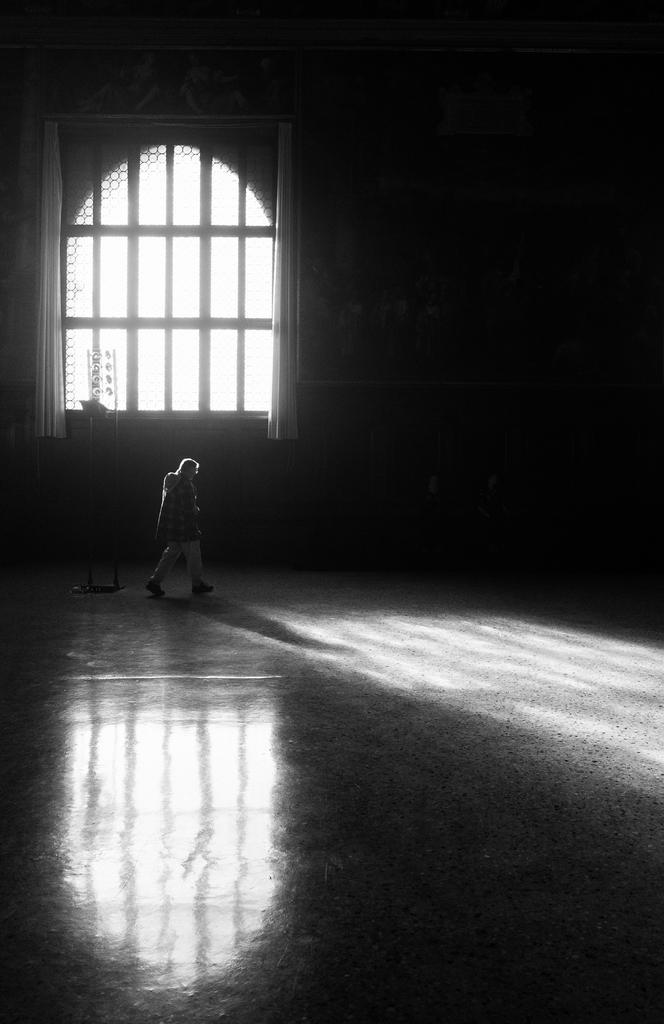Could you give a brief overview of what you see in this image? This image consists of a person walking. At the bottom, there is a floor. In the background, there is a window along with a curtain and a wall. 